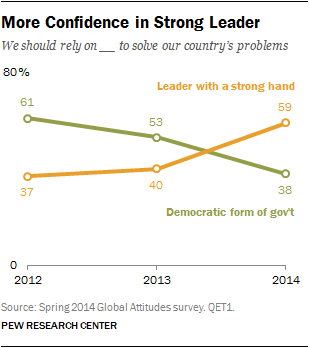Highlight a few significant elements in this photo. The green line indicates the presence of a democratic form of government. The median of values on the green line is greater than the median of values on the orange line. 